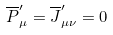Convert formula to latex. <formula><loc_0><loc_0><loc_500><loc_500>\overline { P } _ { \mu } ^ { \prime } = \overline { J } _ { \mu \nu } ^ { \prime } = 0</formula> 